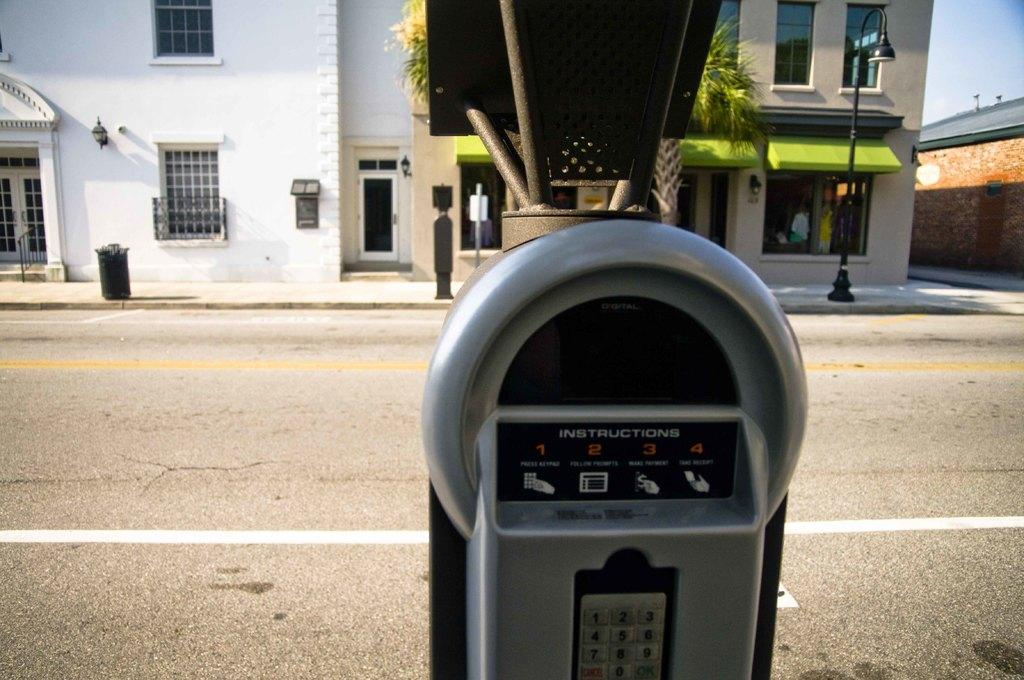<image>
Create a compact narrative representing the image presented. A parking meter that says instructions on it. 